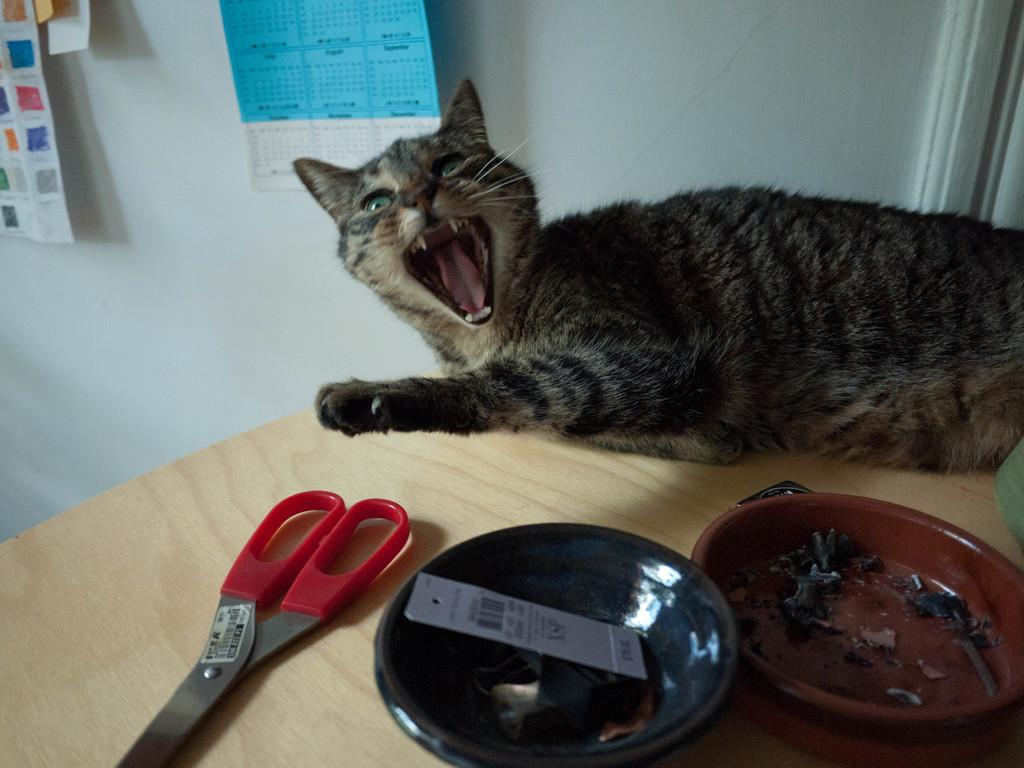What animal is on the table in the image? There is a cat on the table in the image. What objects are on the table besides the cat? There are scissors and bowls on the table. What can be seen in the background of the image? There is a wall in the background of the image. What is on the wall in the background? There are posters on the wall in the background. What type of chalk is being used by the cat in the image? There is no chalk present in the image, and the cat is not using any chalk. What type of vessel is being used to hold the kite in the image? There is no kite present in the image, and therefore no vessel is being used to hold it. 